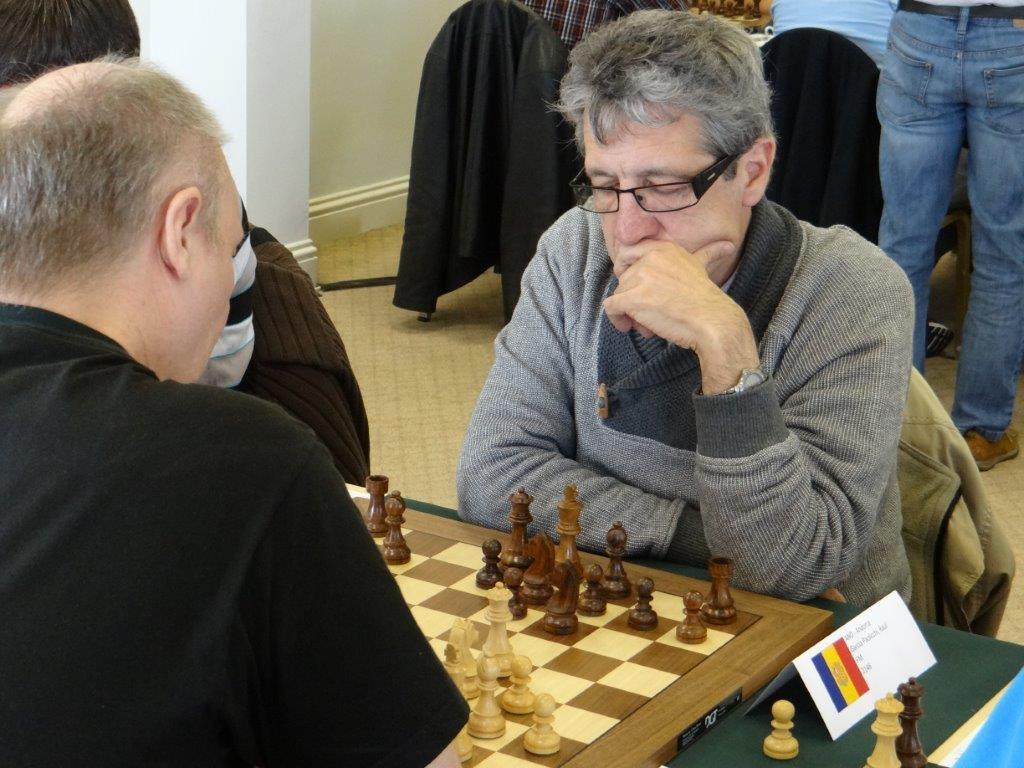What are the persons in the image doing while sitting on the table? The persons are playing chess. What can be seen in the background of the image? There are chairs, persons, and a wall in the background. How many people are playing chess in the image? There are two persons playing chess in the image. What type of alley can be seen in the background of the image? There is no alley present in the image; it features a wall in the background. How does the view of the chessboard change when the players rub their hands together? There is no indication in the image that the players are rubbing their hands together, and the view of the chessboard remains unchanged. 